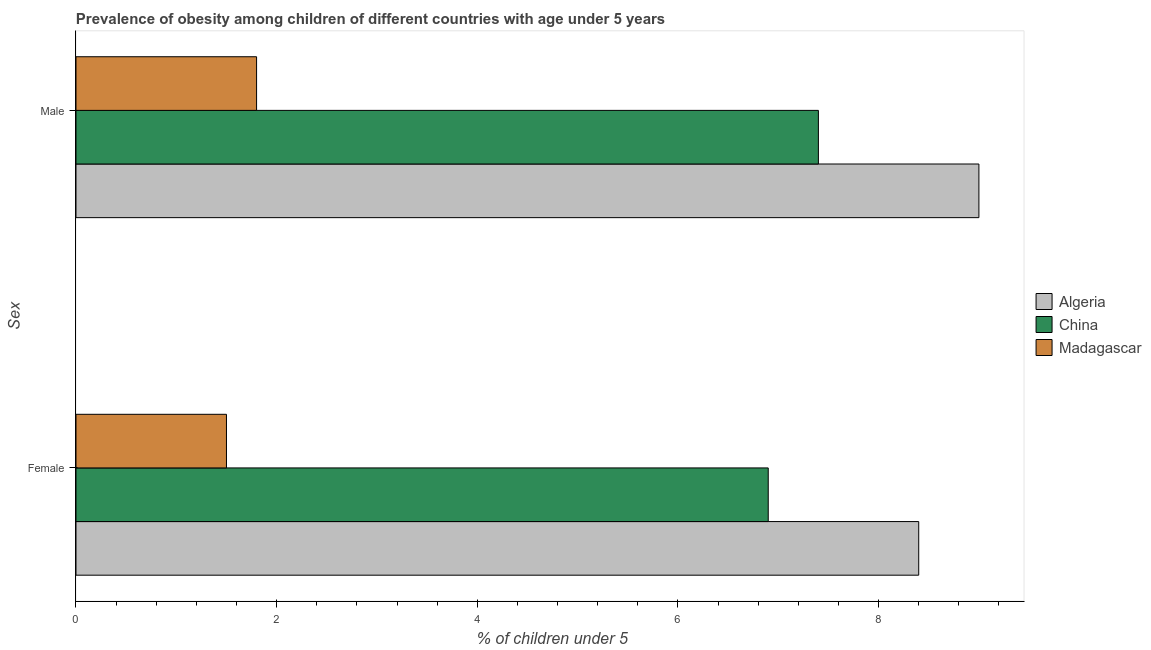How many different coloured bars are there?
Your answer should be compact. 3. How many groups of bars are there?
Your answer should be very brief. 2. Are the number of bars on each tick of the Y-axis equal?
Your response must be concise. Yes. How many bars are there on the 1st tick from the top?
Your response must be concise. 3. What is the label of the 2nd group of bars from the top?
Your answer should be compact. Female. What is the percentage of obese female children in China?
Keep it short and to the point. 6.9. Across all countries, what is the maximum percentage of obese female children?
Provide a succinct answer. 8.4. In which country was the percentage of obese male children maximum?
Offer a terse response. Algeria. In which country was the percentage of obese female children minimum?
Keep it short and to the point. Madagascar. What is the total percentage of obese male children in the graph?
Offer a terse response. 18.2. What is the difference between the percentage of obese male children in Madagascar and that in China?
Provide a succinct answer. -5.6. What is the difference between the percentage of obese male children in Madagascar and the percentage of obese female children in China?
Provide a short and direct response. -5.1. What is the average percentage of obese male children per country?
Provide a short and direct response. 6.07. What is the difference between the percentage of obese female children and percentage of obese male children in Algeria?
Ensure brevity in your answer.  -0.6. In how many countries, is the percentage of obese male children greater than 1.6 %?
Provide a succinct answer. 3. What is the ratio of the percentage of obese male children in Madagascar to that in China?
Ensure brevity in your answer.  0.24. In how many countries, is the percentage of obese male children greater than the average percentage of obese male children taken over all countries?
Your answer should be very brief. 2. What does the 1st bar from the top in Female represents?
Provide a succinct answer. Madagascar. What does the 3rd bar from the bottom in Male represents?
Provide a succinct answer. Madagascar. How many countries are there in the graph?
Keep it short and to the point. 3. What is the difference between two consecutive major ticks on the X-axis?
Make the answer very short. 2. Does the graph contain grids?
Provide a short and direct response. No. Where does the legend appear in the graph?
Your answer should be compact. Center right. How are the legend labels stacked?
Offer a very short reply. Vertical. What is the title of the graph?
Your answer should be compact. Prevalence of obesity among children of different countries with age under 5 years. What is the label or title of the X-axis?
Provide a short and direct response.  % of children under 5. What is the label or title of the Y-axis?
Your response must be concise. Sex. What is the  % of children under 5 in Algeria in Female?
Offer a terse response. 8.4. What is the  % of children under 5 in China in Female?
Give a very brief answer. 6.9. What is the  % of children under 5 in Madagascar in Female?
Your answer should be very brief. 1.5. What is the  % of children under 5 in Algeria in Male?
Your answer should be very brief. 9. What is the  % of children under 5 of China in Male?
Ensure brevity in your answer.  7.4. What is the  % of children under 5 of Madagascar in Male?
Ensure brevity in your answer.  1.8. Across all Sex, what is the maximum  % of children under 5 in Algeria?
Your answer should be very brief. 9. Across all Sex, what is the maximum  % of children under 5 in China?
Offer a very short reply. 7.4. Across all Sex, what is the maximum  % of children under 5 in Madagascar?
Keep it short and to the point. 1.8. Across all Sex, what is the minimum  % of children under 5 in Algeria?
Offer a very short reply. 8.4. Across all Sex, what is the minimum  % of children under 5 in China?
Make the answer very short. 6.9. What is the total  % of children under 5 of China in the graph?
Offer a very short reply. 14.3. What is the total  % of children under 5 of Madagascar in the graph?
Make the answer very short. 3.3. What is the difference between the  % of children under 5 of Algeria in Female and that in Male?
Make the answer very short. -0.6. What is the difference between the  % of children under 5 in China in Female and that in Male?
Provide a short and direct response. -0.5. What is the difference between the  % of children under 5 in Algeria in Female and the  % of children under 5 in Madagascar in Male?
Make the answer very short. 6.6. What is the average  % of children under 5 in China per Sex?
Make the answer very short. 7.15. What is the average  % of children under 5 of Madagascar per Sex?
Your response must be concise. 1.65. What is the difference between the  % of children under 5 in Algeria and  % of children under 5 in China in Female?
Your response must be concise. 1.5. What is the difference between the  % of children under 5 of China and  % of children under 5 of Madagascar in Male?
Your answer should be very brief. 5.6. What is the ratio of the  % of children under 5 in China in Female to that in Male?
Keep it short and to the point. 0.93. What is the ratio of the  % of children under 5 in Madagascar in Female to that in Male?
Ensure brevity in your answer.  0.83. What is the difference between the highest and the second highest  % of children under 5 of Algeria?
Ensure brevity in your answer.  0.6. What is the difference between the highest and the second highest  % of children under 5 in Madagascar?
Your answer should be compact. 0.3. What is the difference between the highest and the lowest  % of children under 5 in Algeria?
Provide a short and direct response. 0.6. What is the difference between the highest and the lowest  % of children under 5 in China?
Keep it short and to the point. 0.5. 